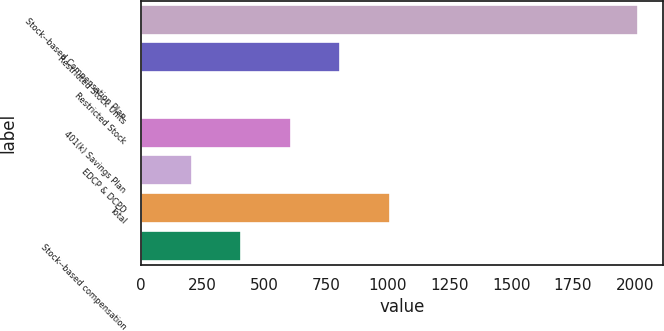Convert chart. <chart><loc_0><loc_0><loc_500><loc_500><bar_chart><fcel>Stock-­based Compensation Plan<fcel>Restricted Stock Units<fcel>Restricted Stock<fcel>401(k) Savings Plan<fcel>EDCP & DCPD<fcel>Total<fcel>Stock-­based compensation<nl><fcel>2014<fcel>808.6<fcel>5<fcel>607.7<fcel>205.9<fcel>1009.5<fcel>406.8<nl></chart> 